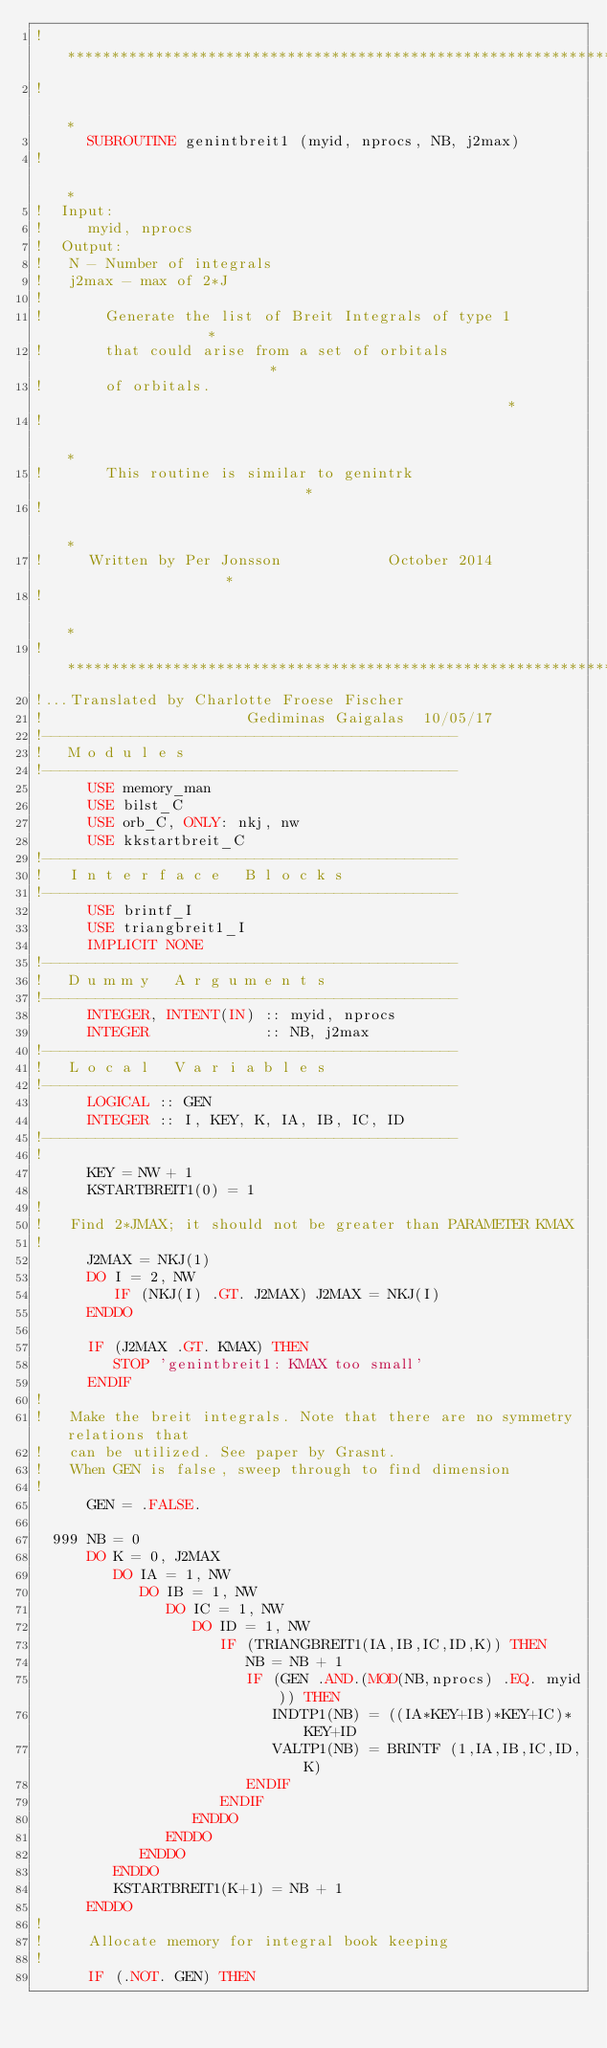<code> <loc_0><loc_0><loc_500><loc_500><_FORTRAN_>!***********************************************************************
!                                                                      *
      SUBROUTINE genintbreit1 (myid, nprocs, NB, j2max)
!                                                                      *
!  Input:
!     myid, nprocs
!  Output:
!   N - Number of integrals
!   j2max - max of 2*J
!
!       Generate the list of Breit Integrals of type 1                 *
!       that could arise from a set of orbitals                        *
!       of orbitals.                                                   *
!                                                                      *
!       This routine is similar to genintrk                            *
!                                                                      *
!     Written by Per Jonsson            October 2014                   *
!                                                                      *
!***********************************************************************
!...Translated by Charlotte Froese Fischer
!                       Gediminas Gaigalas  10/05/17
!-----------------------------------------------
!   M o d u l e s
!-----------------------------------------------
      USE memory_man
      USE bilst_C
      USE orb_C, ONLY: nkj, nw
      USE kkstartbreit_C
!-----------------------------------------------
!   I n t e r f a c e   B l o c k s
!-----------------------------------------------
      USE brintf_I
      USE triangbreit1_I
      IMPLICIT NONE
!-----------------------------------------------
!   D u m m y   A r g u m e n t s
!-----------------------------------------------
      INTEGER, INTENT(IN) :: myid, nprocs
      INTEGER             :: NB, j2max
!-----------------------------------------------
!   L o c a l   V a r i a b l e s
!-----------------------------------------------
      LOGICAL :: GEN
      INTEGER :: I, KEY, K, IA, IB, IC, ID
!-----------------------------------------------
!
      KEY = NW + 1
      KSTARTBREIT1(0) = 1
!
!   Find 2*JMAX; it should not be greater than PARAMETER KMAX
!
      J2MAX = NKJ(1)
      DO I = 2, NW
         IF (NKJ(I) .GT. J2MAX) J2MAX = NKJ(I)
      ENDDO

      IF (J2MAX .GT. KMAX) THEN
         STOP 'genintbreit1: KMAX too small'
      ENDIF
!
!   Make the breit integrals. Note that there are no symmetry relations that
!   can be utilized. See paper by Grasnt.
!   When GEN is false, sweep through to find dimension
!
      GEN = .FALSE.

  999 NB = 0
      DO K = 0, J2MAX
         DO IA = 1, NW
            DO IB = 1, NW
               DO IC = 1, NW
                  DO ID = 1, NW
                     IF (TRIANGBREIT1(IA,IB,IC,ID,K)) THEN
                        NB = NB + 1
                        IF (GEN .AND.(MOD(NB,nprocs) .EQ. myid)) THEN
                           INDTP1(NB) = ((IA*KEY+IB)*KEY+IC)*KEY+ID
                           VALTP1(NB) = BRINTF (1,IA,IB,IC,ID,K)
                        ENDIF
                     ENDIF
                  ENDDO
               ENDDO
            ENDDO
         ENDDO
         KSTARTBREIT1(K+1) = NB + 1
      ENDDO
!
!     Allocate memory for integral book keeping
!
      IF (.NOT. GEN) THEN</code> 